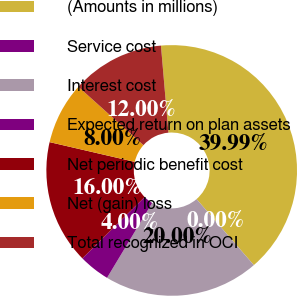Convert chart to OTSL. <chart><loc_0><loc_0><loc_500><loc_500><pie_chart><fcel>(Amounts in millions)<fcel>Service cost<fcel>Interest cost<fcel>Expected return on plan assets<fcel>Net periodic benefit cost<fcel>Net (gain) loss<fcel>Total recognized in OCI<nl><fcel>39.99%<fcel>0.0%<fcel>20.0%<fcel>4.0%<fcel>16.0%<fcel>8.0%<fcel>12.0%<nl></chart> 